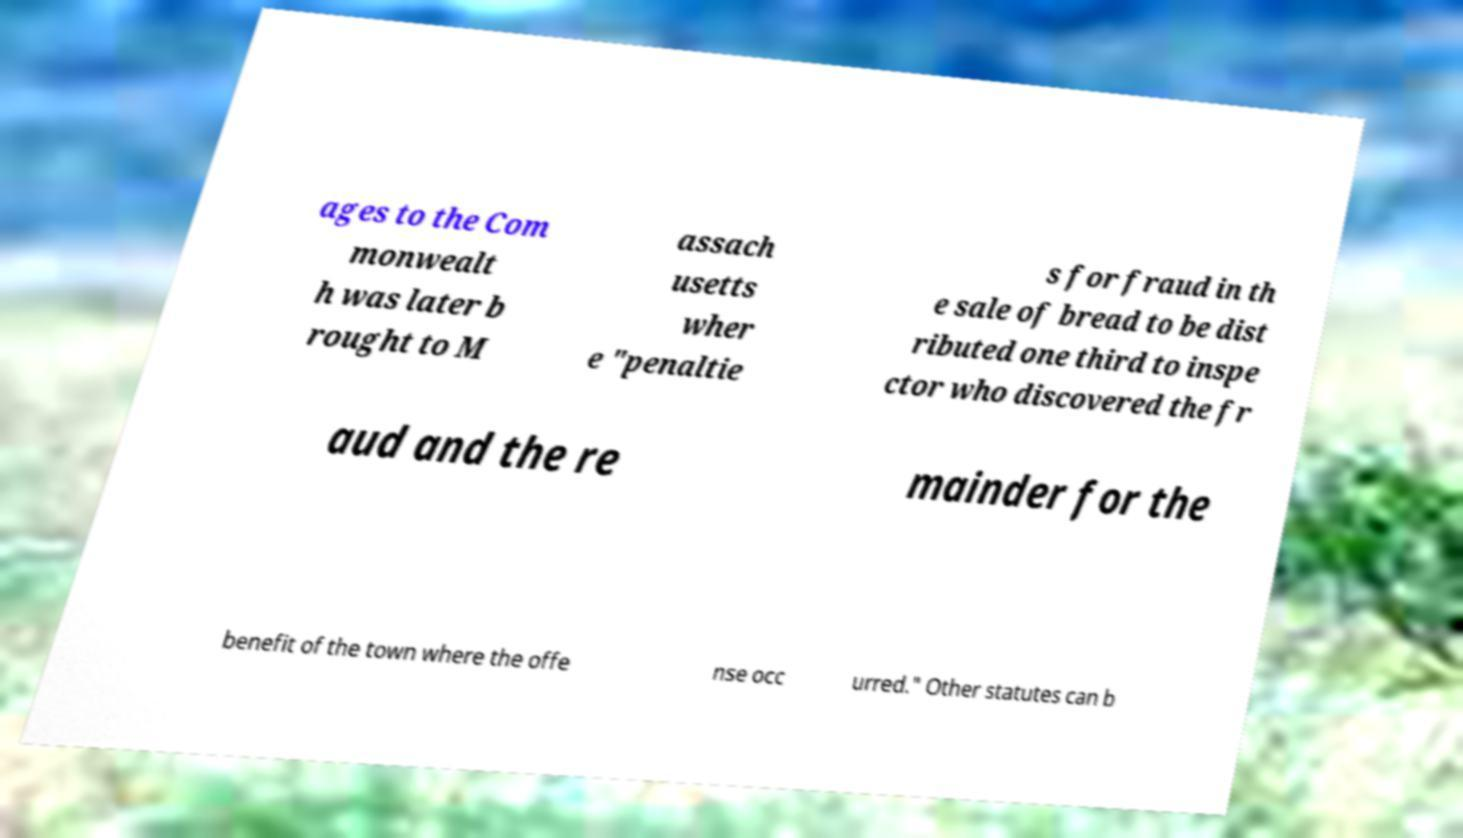Can you accurately transcribe the text from the provided image for me? ages to the Com monwealt h was later b rought to M assach usetts wher e "penaltie s for fraud in th e sale of bread to be dist ributed one third to inspe ctor who discovered the fr aud and the re mainder for the benefit of the town where the offe nse occ urred." Other statutes can b 